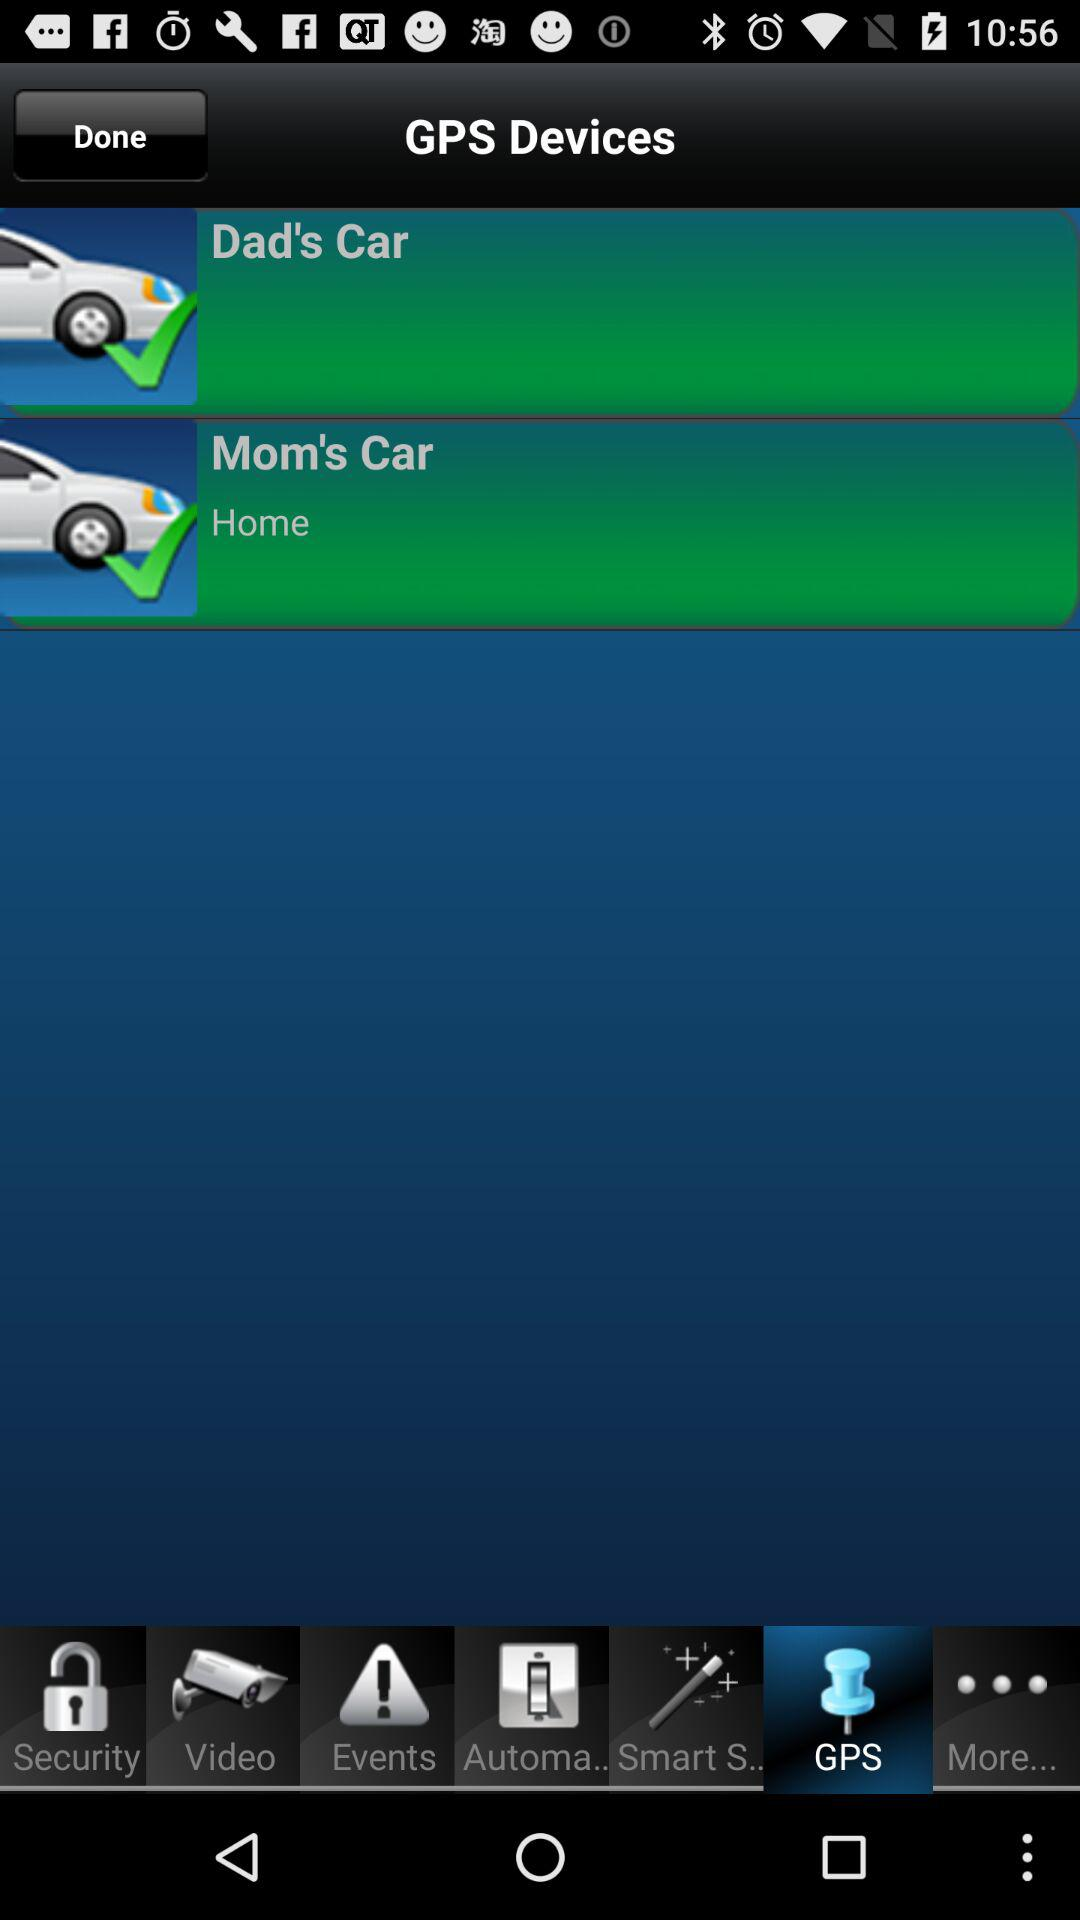How many "Events" are there?
When the provided information is insufficient, respond with <no answer>. <no answer> 